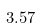Convert formula to latex. <formula><loc_0><loc_0><loc_500><loc_500>3 . 5 7</formula> 